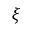Convert formula to latex. <formula><loc_0><loc_0><loc_500><loc_500>\xi</formula> 